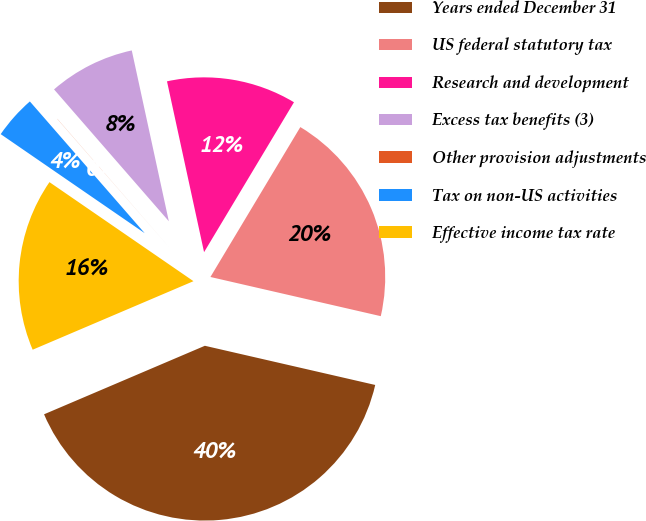<chart> <loc_0><loc_0><loc_500><loc_500><pie_chart><fcel>Years ended December 31<fcel>US federal statutory tax<fcel>Research and development<fcel>Excess tax benefits (3)<fcel>Other provision adjustments<fcel>Tax on non-US activities<fcel>Effective income tax rate<nl><fcel>39.99%<fcel>20.0%<fcel>12.0%<fcel>8.0%<fcel>0.01%<fcel>4.0%<fcel>16.0%<nl></chart> 